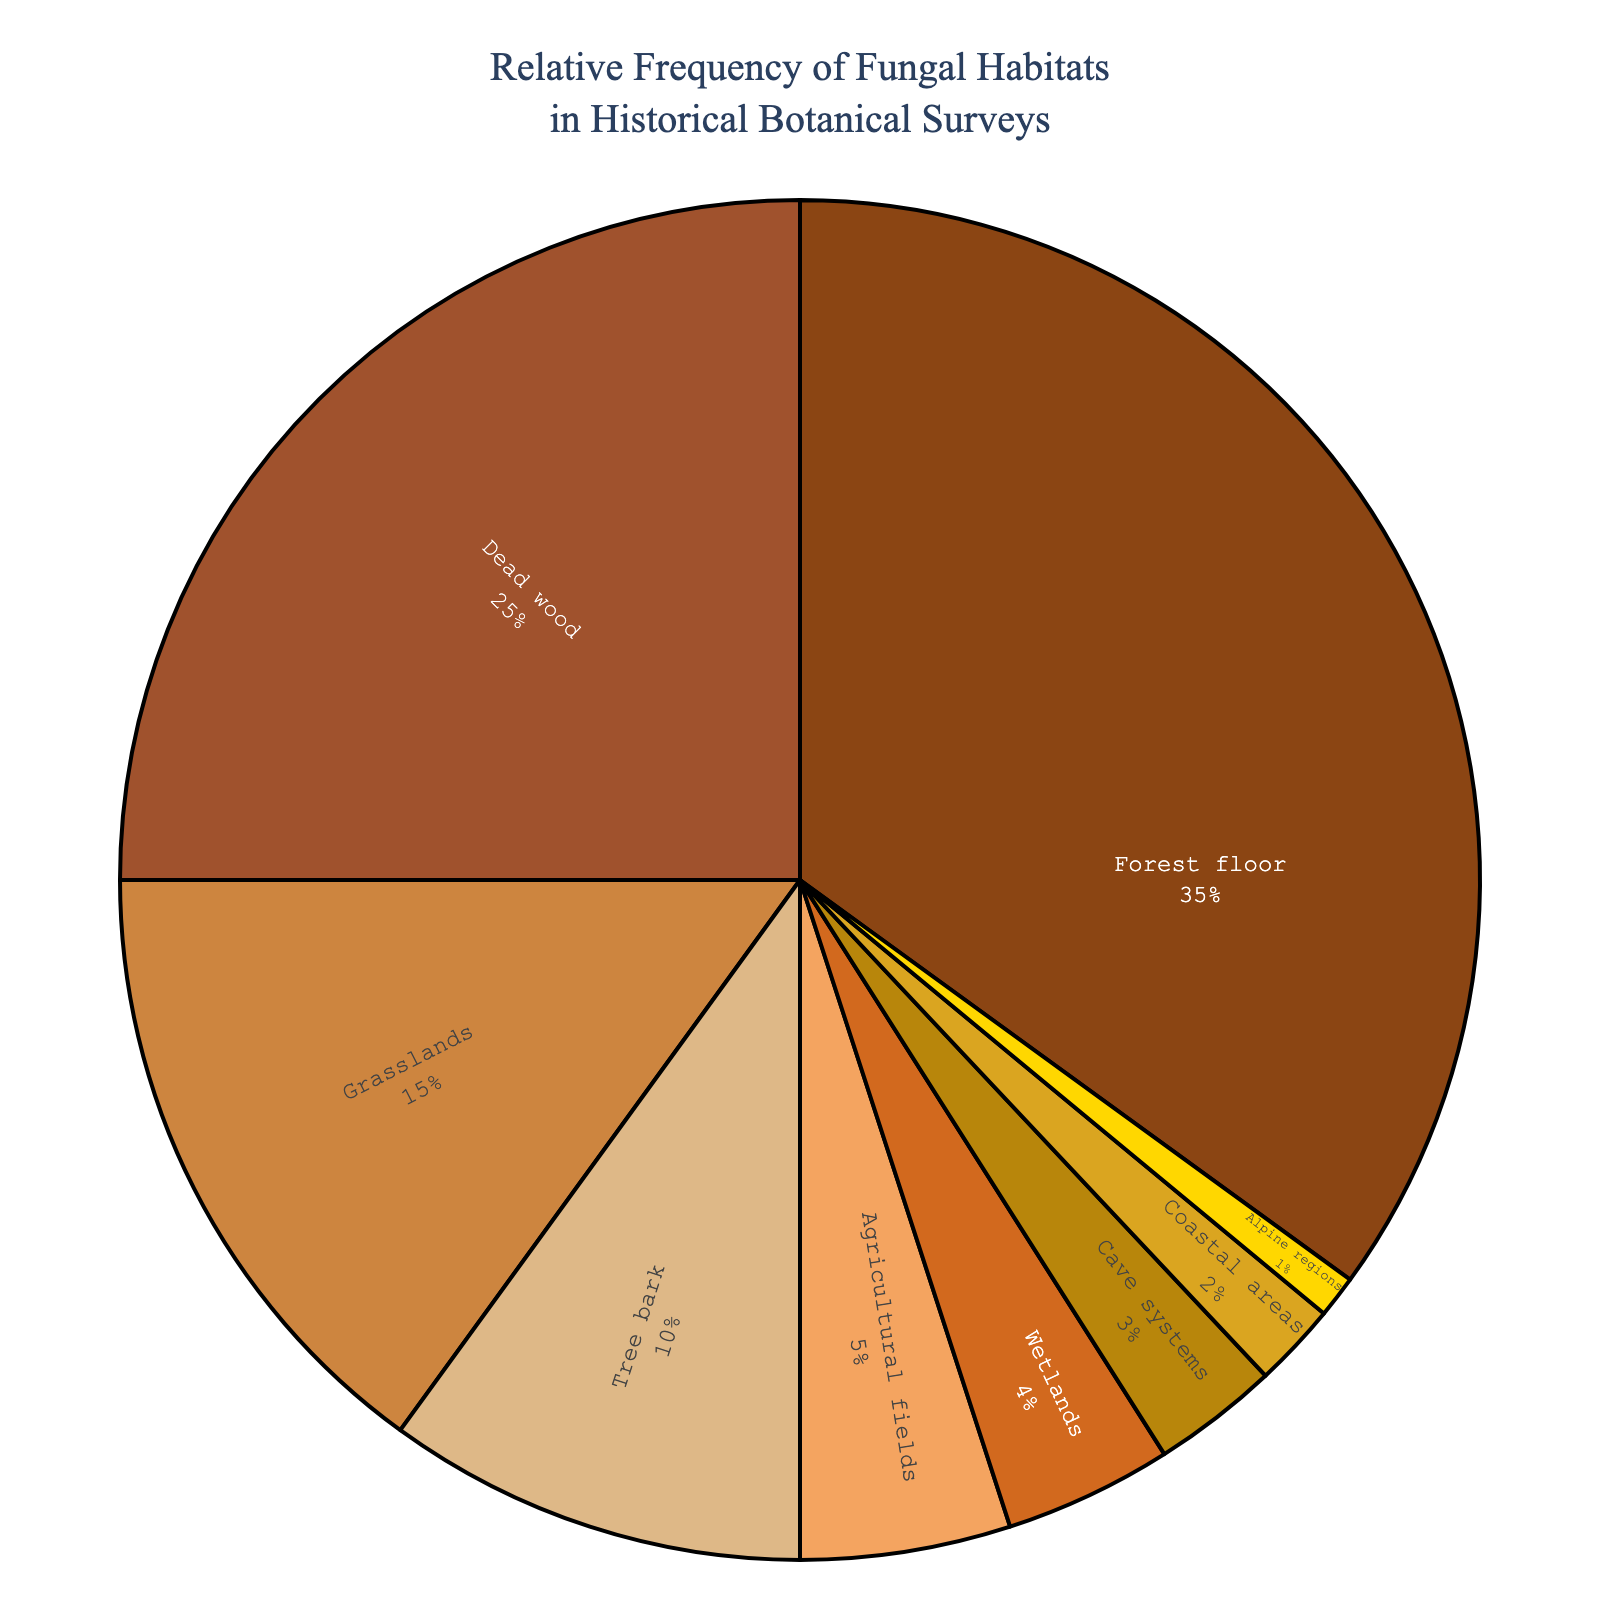Which habitat has the highest relative frequency? The habitat with the largest segment in the pie chart has the highest relative frequency. It is labeled as "Forest floor" and takes up 35% of the chart.
Answer: Forest floor Which two habitats together account for more than 50% of the frequency? The two largest segments together should add up to more than 50%. "Forest floor" has 35% and "Dead wood" has 25%, which together total 60%.
Answer: Forest floor and Dead wood What's the percentage difference between the frequencies of tree bark and grasslands? Grasslands has 15% while Tree bark has 10%. The difference is 15% - 10% = 5%.
Answer: 5% Which habitats have the same color shade? Inspect the pie chart for segments with similar color shades. "Agricultural fields" and "Wetlands" have very similar shades of light brown.
Answer: Agricultural fields and Wetlands How many habitats have a frequency less than 5%? Count the segments labeled with percentages under 5%. These are Wetlands (4%), Cave systems (3%), Coastal areas (2%), and Alpine regions (1%). In total, there are 4 habitats.
Answer: 4 What is the total percentage for all habitats that have a frequency less than 10%? Sum up the percentages for Tree bark (10%), Agricultural fields (5%), Wetlands (4%), Cave systems (3%), Coastal areas (2%), and Alpine regions (1%). The total is 10% + 5% + 4% + 3% + 2% + 1% = 25%.
Answer: 25% Which habitat is represented by the golden color? The label for the golden-colored segment is "Alpine regions." This color stands out due to its brightness.
Answer: Alpine regions Which habitat is more common: coastal areas or cave systems? Find the segments labeled "Coastal areas" and "Cave systems" and compare their percentages. Coastal areas have 2% while Cave systems have 3%.
Answer: Cave systems What is the ratio of the frequency of dead wood to the frequency of agricultural fields? The frequency for Dead wood is 25% and for Agricultural fields is 5%. The ratio is 25% / 5% = 5:1.
Answer: 5:1 What is the sum of the relative frequencies of grasslands, tree bark, and coastal areas? Add up the percentages for Grasslands (15%), Tree bark (10%), and Coastal areas (2%). The total is 15% + 10% + 2% = 27%.
Answer: 27% 